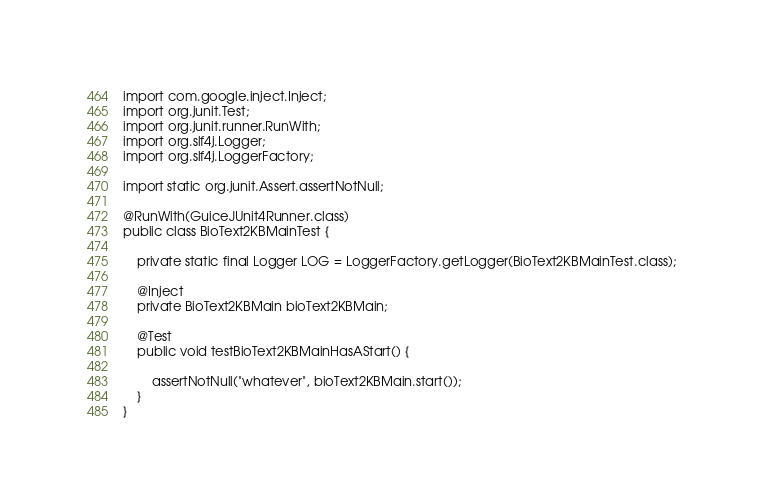Convert code to text. <code><loc_0><loc_0><loc_500><loc_500><_Java_>import com.google.inject.Inject;
import org.junit.Test;
import org.junit.runner.RunWith;
import org.slf4j.Logger;
import org.slf4j.LoggerFactory;

import static org.junit.Assert.assertNotNull;

@RunWith(GuiceJUnit4Runner.class)
public class BioText2KBMainTest {

    private static final Logger LOG = LoggerFactory.getLogger(BioText2KBMainTest.class);

    @Inject
    private BioText2KBMain bioText2KBMain;

    @Test
    public void testBioText2KBMainHasAStart() {

        assertNotNull("whatever", bioText2KBMain.start());
    }
}
</code> 